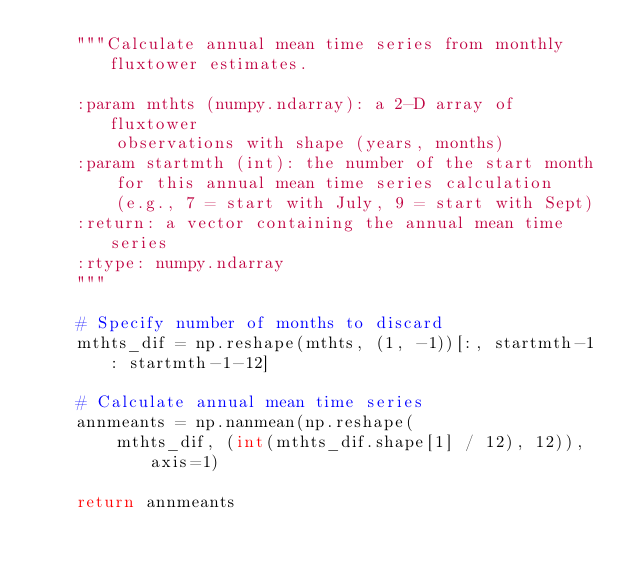<code> <loc_0><loc_0><loc_500><loc_500><_Python_>    """Calculate annual mean time series from monthly fluxtower estimates.
    
    :param mthts (numpy.ndarray): a 2-D array of fluxtower 
        observations with shape (years, months)
    :param startmth (int): the number of the start month
        for this annual mean time series calculation
        (e.g., 7 = start with July, 9 = start with Sept)
    :return: a vector containing the annual mean time series
    :rtype: numpy.ndarray
    """
    
    # Specify number of months to discard
    mthts_dif = np.reshape(mthts, (1, -1))[:, startmth-1 : startmth-1-12]
    
    # Calculate annual mean time series
    annmeants = np.nanmean(np.reshape(
        mthts_dif, (int(mthts_dif.shape[1] / 12), 12)), axis=1)
    
    return annmeants
</code> 